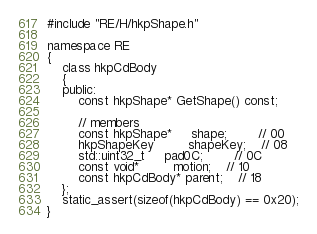<code> <loc_0><loc_0><loc_500><loc_500><_C_>#include "RE/H/hkpShape.h"

namespace RE
{
	class hkpCdBody
	{
	public:
		const hkpShape* GetShape() const;

		// members
		const hkpShape*	 shape;		// 00
		hkpShapeKey		 shapeKey;	// 08
		std::uint32_t	 pad0C;		// 0C
		const void*		 motion;	// 10
		const hkpCdBody* parent;	// 18
	};
	static_assert(sizeof(hkpCdBody) == 0x20);
}
</code> 